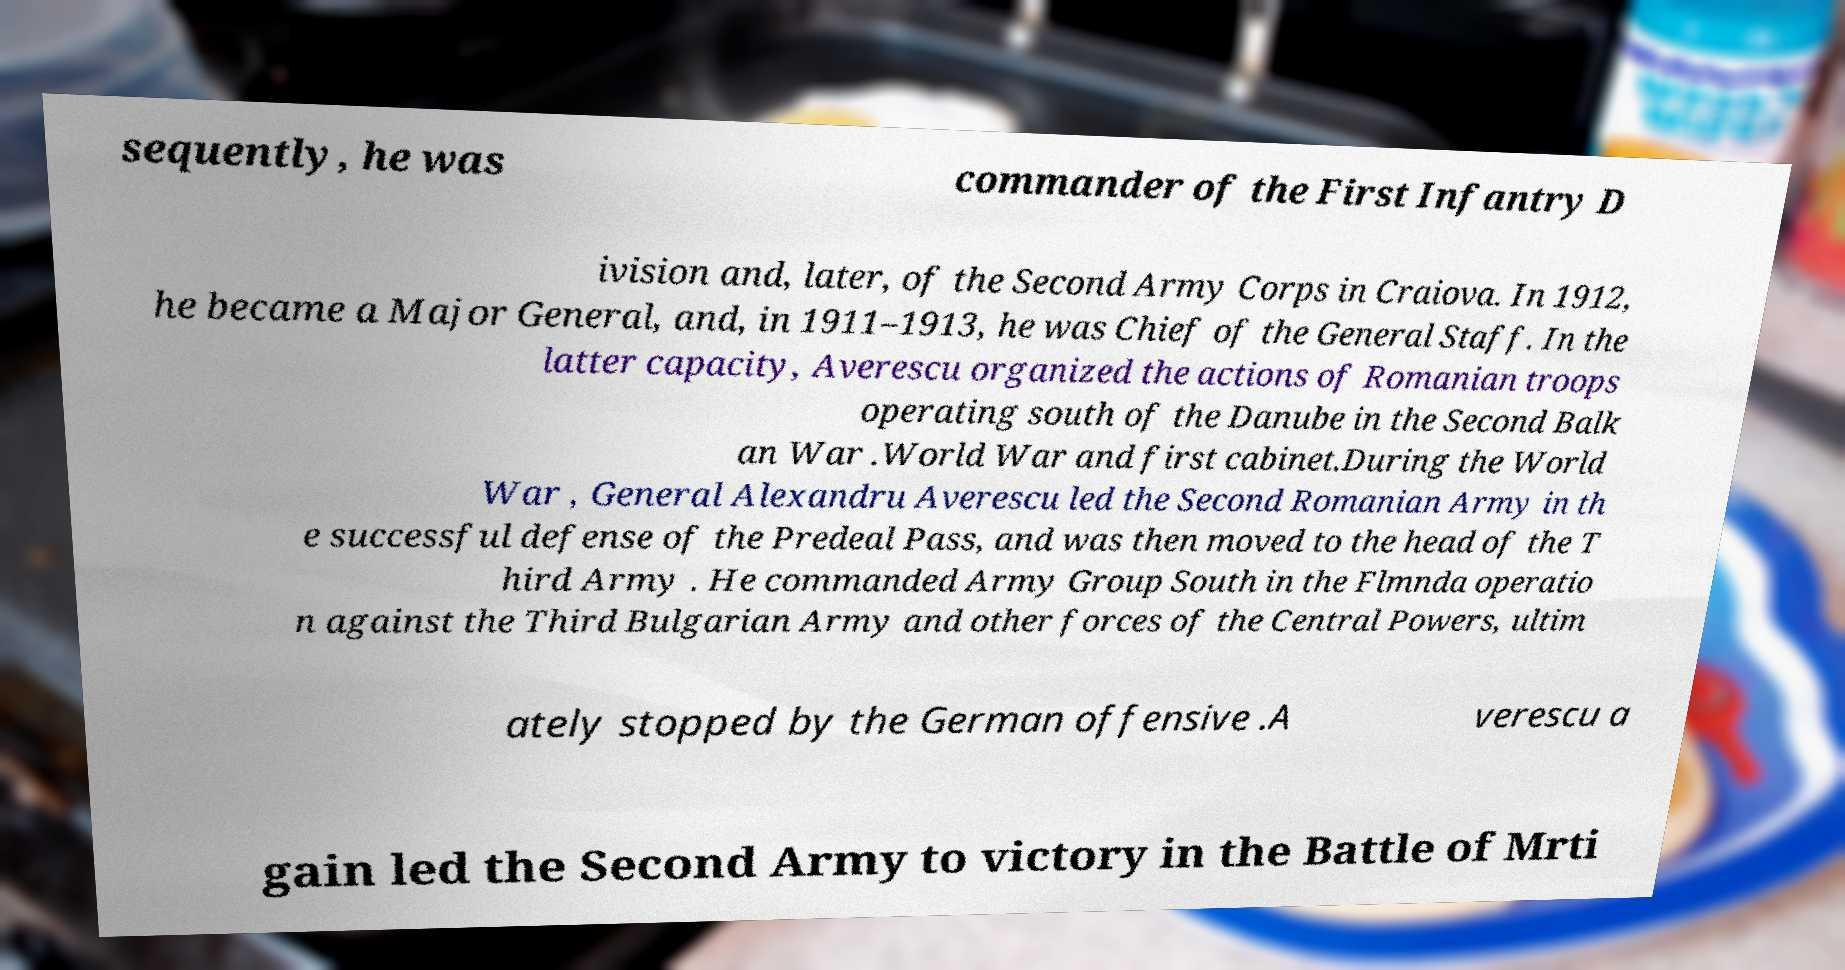There's text embedded in this image that I need extracted. Can you transcribe it verbatim? sequently, he was commander of the First Infantry D ivision and, later, of the Second Army Corps in Craiova. In 1912, he became a Major General, and, in 1911–1913, he was Chief of the General Staff. In the latter capacity, Averescu organized the actions of Romanian troops operating south of the Danube in the Second Balk an War .World War and first cabinet.During the World War , General Alexandru Averescu led the Second Romanian Army in th e successful defense of the Predeal Pass, and was then moved to the head of the T hird Army . He commanded Army Group South in the Flmnda operatio n against the Third Bulgarian Army and other forces of the Central Powers, ultim ately stopped by the German offensive .A verescu a gain led the Second Army to victory in the Battle of Mrti 